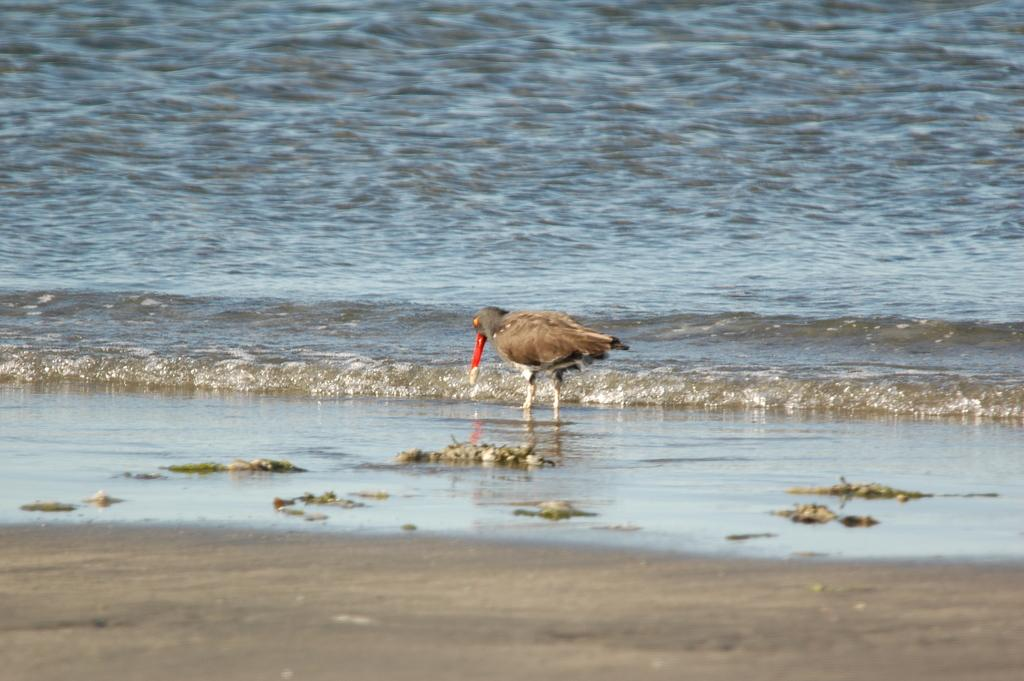What type of animal can be seen in the image? There is a bird in the image. Where is the bird located in the image? The bird is standing near the seashore. What is the main setting of the image? The image depicts a sea. What is the primary feature of the sea in the image? Water is flowing in the image. How many pumpkins are visible in the image? There are no pumpkins present in the image. What type of things are the birds using to fly in the image? The image does not depict birds flying, and there are no objects mentioned that would enable them to fly. 